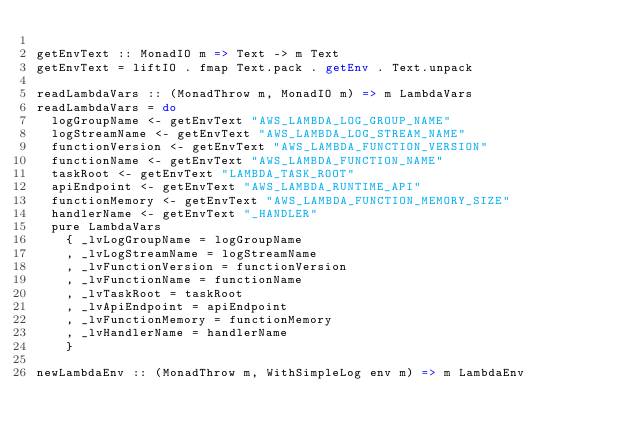<code> <loc_0><loc_0><loc_500><loc_500><_Haskell_>
getEnvText :: MonadIO m => Text -> m Text
getEnvText = liftIO . fmap Text.pack . getEnv . Text.unpack

readLambdaVars :: (MonadThrow m, MonadIO m) => m LambdaVars
readLambdaVars = do
  logGroupName <- getEnvText "AWS_LAMBDA_LOG_GROUP_NAME"
  logStreamName <- getEnvText "AWS_LAMBDA_LOG_STREAM_NAME"
  functionVersion <- getEnvText "AWS_LAMBDA_FUNCTION_VERSION"
  functionName <- getEnvText "AWS_LAMBDA_FUNCTION_NAME"
  taskRoot <- getEnvText "LAMBDA_TASK_ROOT"
  apiEndpoint <- getEnvText "AWS_LAMBDA_RUNTIME_API"
  functionMemory <- getEnvText "AWS_LAMBDA_FUNCTION_MEMORY_SIZE"
  handlerName <- getEnvText "_HANDLER"
  pure LambdaVars
    { _lvLogGroupName = logGroupName
    , _lvLogStreamName = logStreamName
    , _lvFunctionVersion = functionVersion
    , _lvFunctionName = functionName
    , _lvTaskRoot = taskRoot
    , _lvApiEndpoint = apiEndpoint
    , _lvFunctionMemory = functionMemory
    , _lvHandlerName = handlerName
    }

newLambdaEnv :: (MonadThrow m, WithSimpleLog env m) => m LambdaEnv</code> 